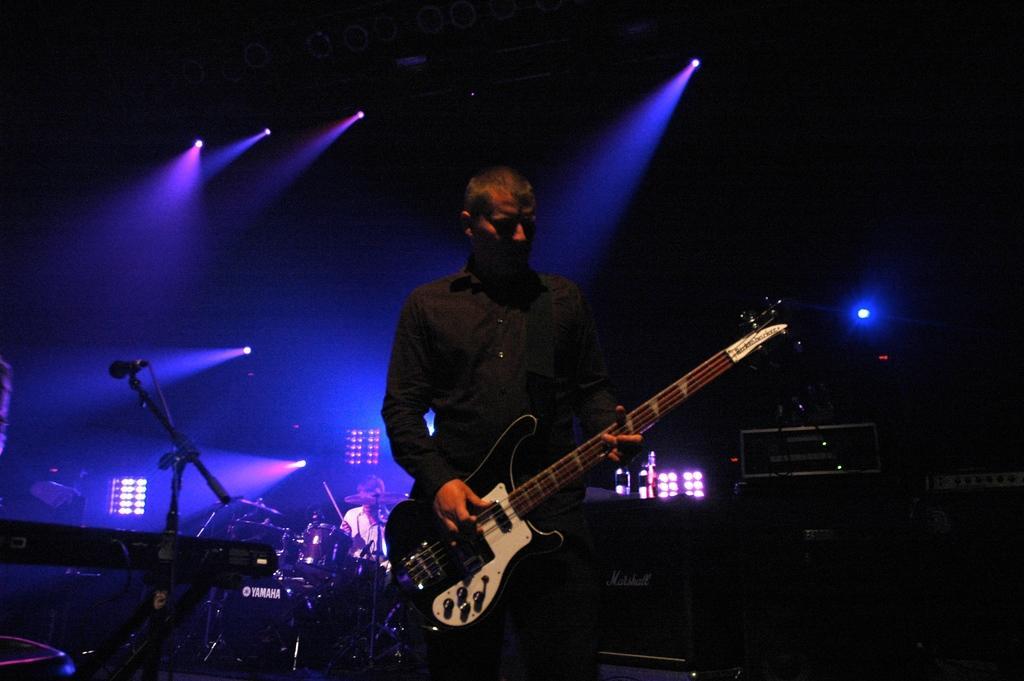Please provide a concise description of this image. Here we can see a man standing and holding a guitar in his hands, and at back here are the musical drums, and here are the lights. 